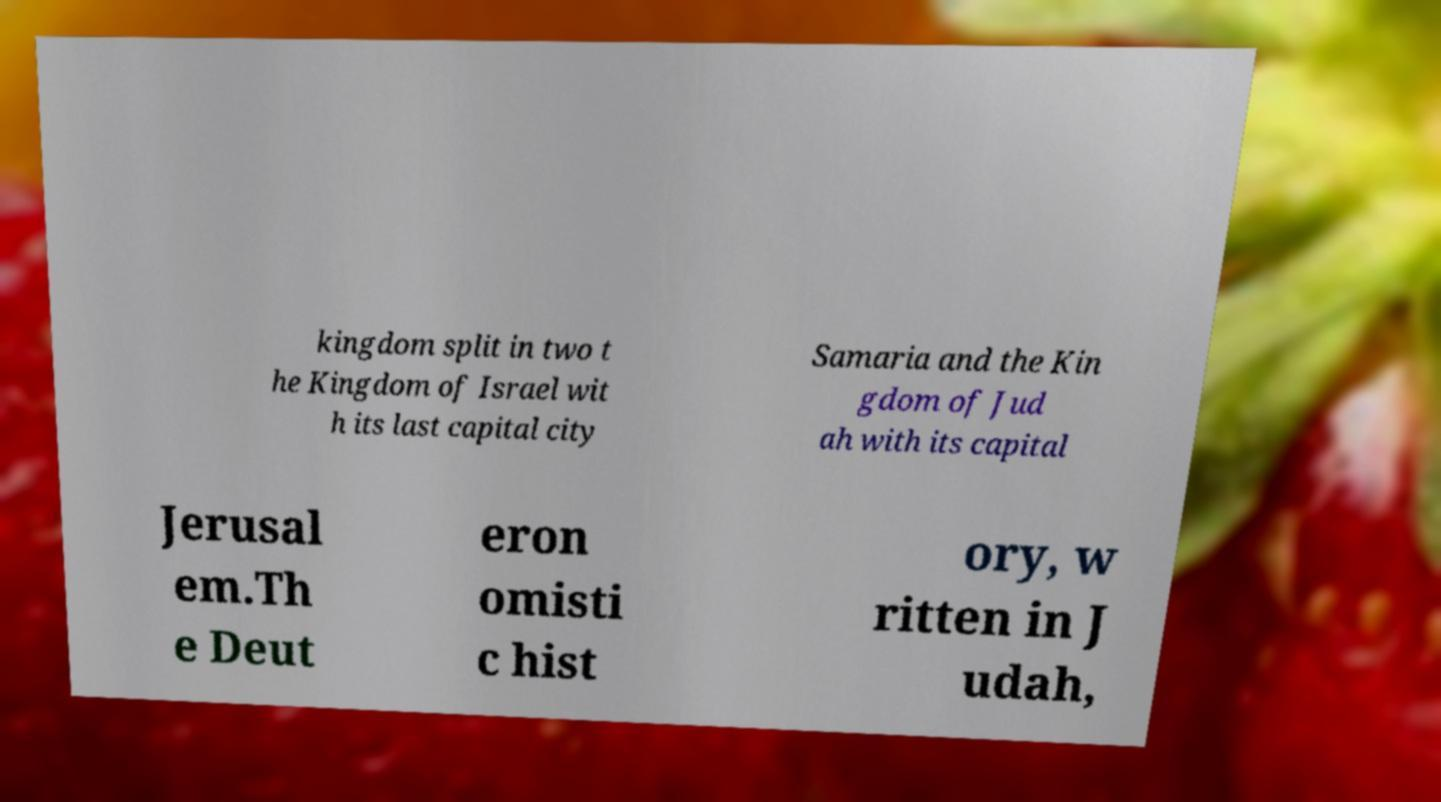For documentation purposes, I need the text within this image transcribed. Could you provide that? kingdom split in two t he Kingdom of Israel wit h its last capital city Samaria and the Kin gdom of Jud ah with its capital Jerusal em.Th e Deut eron omisti c hist ory, w ritten in J udah, 